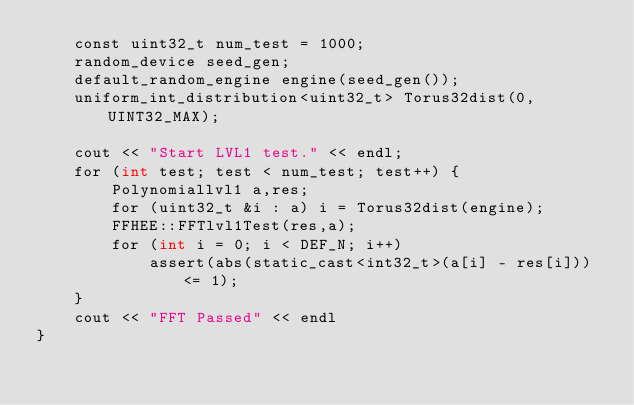Convert code to text. <code><loc_0><loc_0><loc_500><loc_500><_Cuda_>    const uint32_t num_test = 1000;
    random_device seed_gen;
    default_random_engine engine(seed_gen());
    uniform_int_distribution<uint32_t> Torus32dist(0, UINT32_MAX);

    cout << "Start LVL1 test." << endl;
    for (int test; test < num_test; test++) {
        Polynomiallvl1 a,res;
        for (uint32_t &i : a) i = Torus32dist(engine);
        FFHEE::FFTlvl1Test(res,a);
        for (int i = 0; i < DEF_N; i++)
            assert(abs(static_cast<int32_t>(a[i] - res[i])) <= 1);
    }
    cout << "FFT Passed" << endl
}</code> 